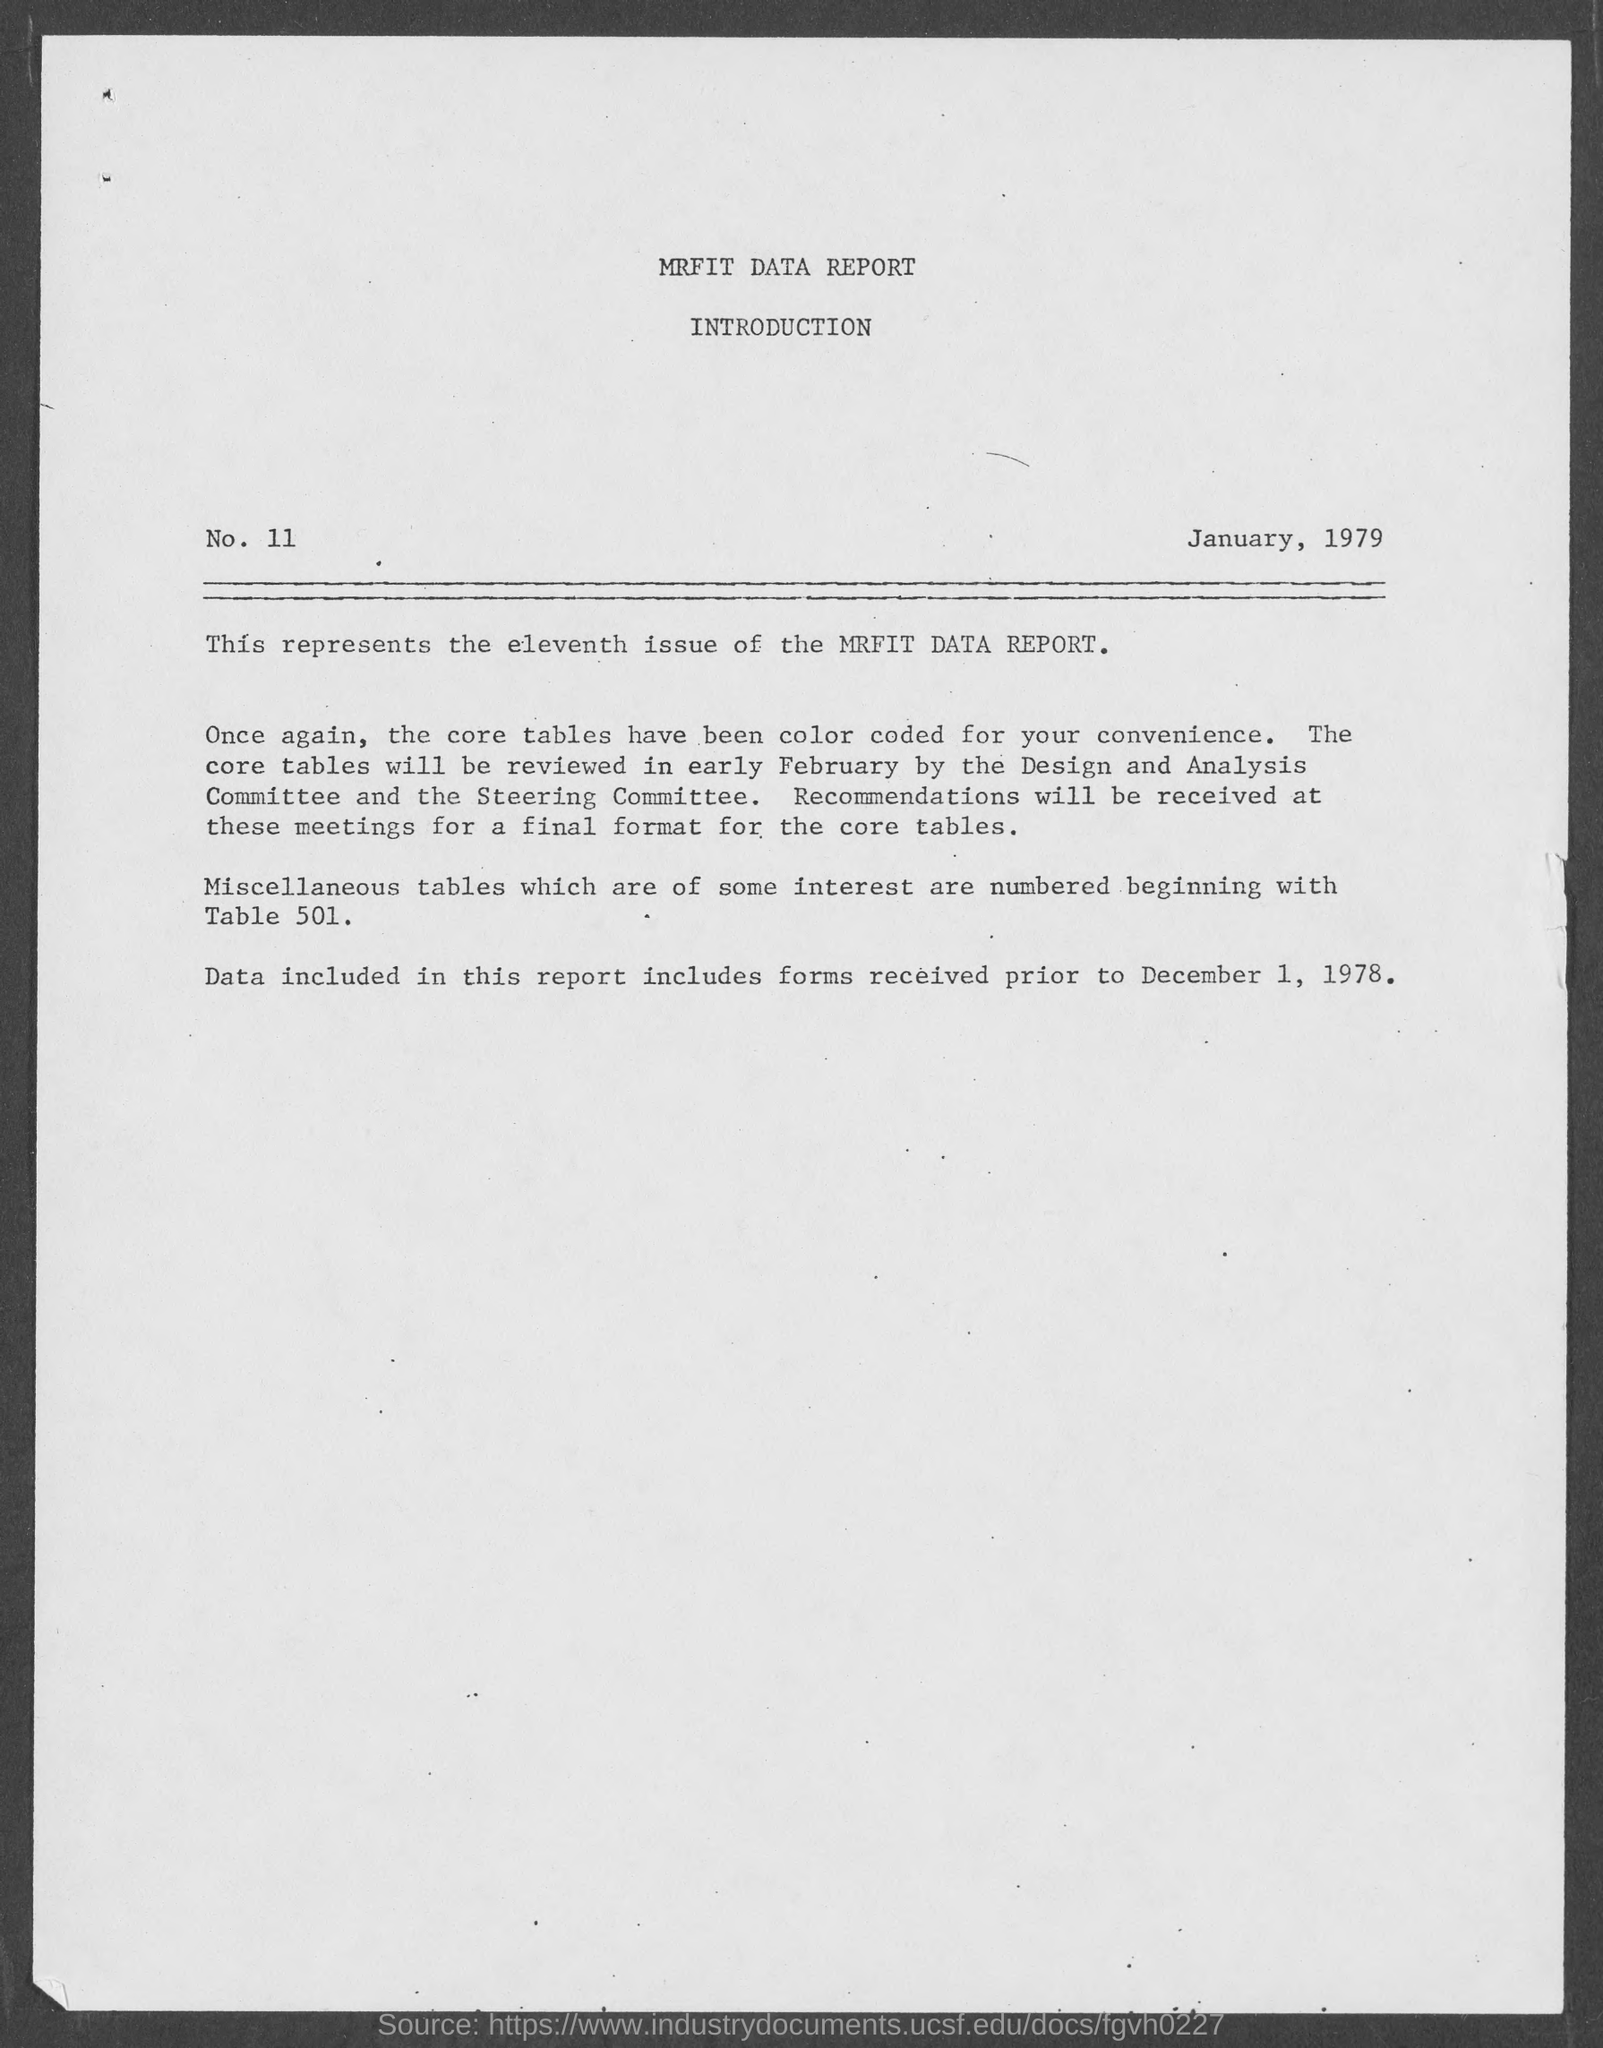What is the date on the report?
Keep it short and to the point. January, 1979. Which issue of the MRFIT  DATA REPORT is shown here ?
Your response must be concise. Eleventh. What has been color coded for the convenience ?
Give a very brief answer. Core tables. What is the title of the report ?
Your response must be concise. MRFIT DATA REPORT. 